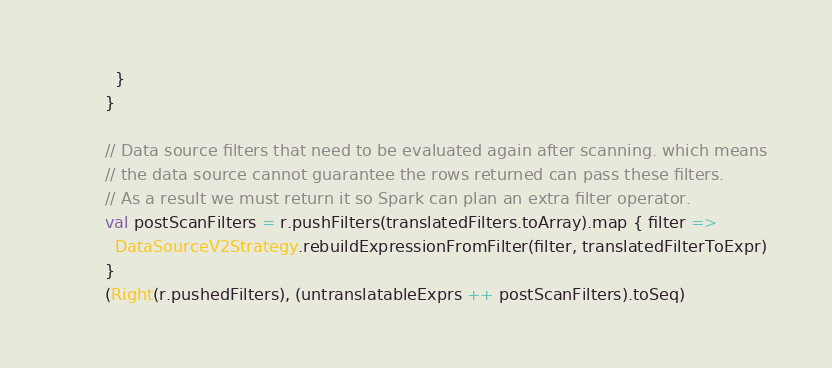<code> <loc_0><loc_0><loc_500><loc_500><_Scala_>          }
        }

        // Data source filters that need to be evaluated again after scanning. which means
        // the data source cannot guarantee the rows returned can pass these filters.
        // As a result we must return it so Spark can plan an extra filter operator.
        val postScanFilters = r.pushFilters(translatedFilters.toArray).map { filter =>
          DataSourceV2Strategy.rebuildExpressionFromFilter(filter, translatedFilterToExpr)
        }
        (Right(r.pushedFilters), (untranslatableExprs ++ postScanFilters).toSeq)
</code> 